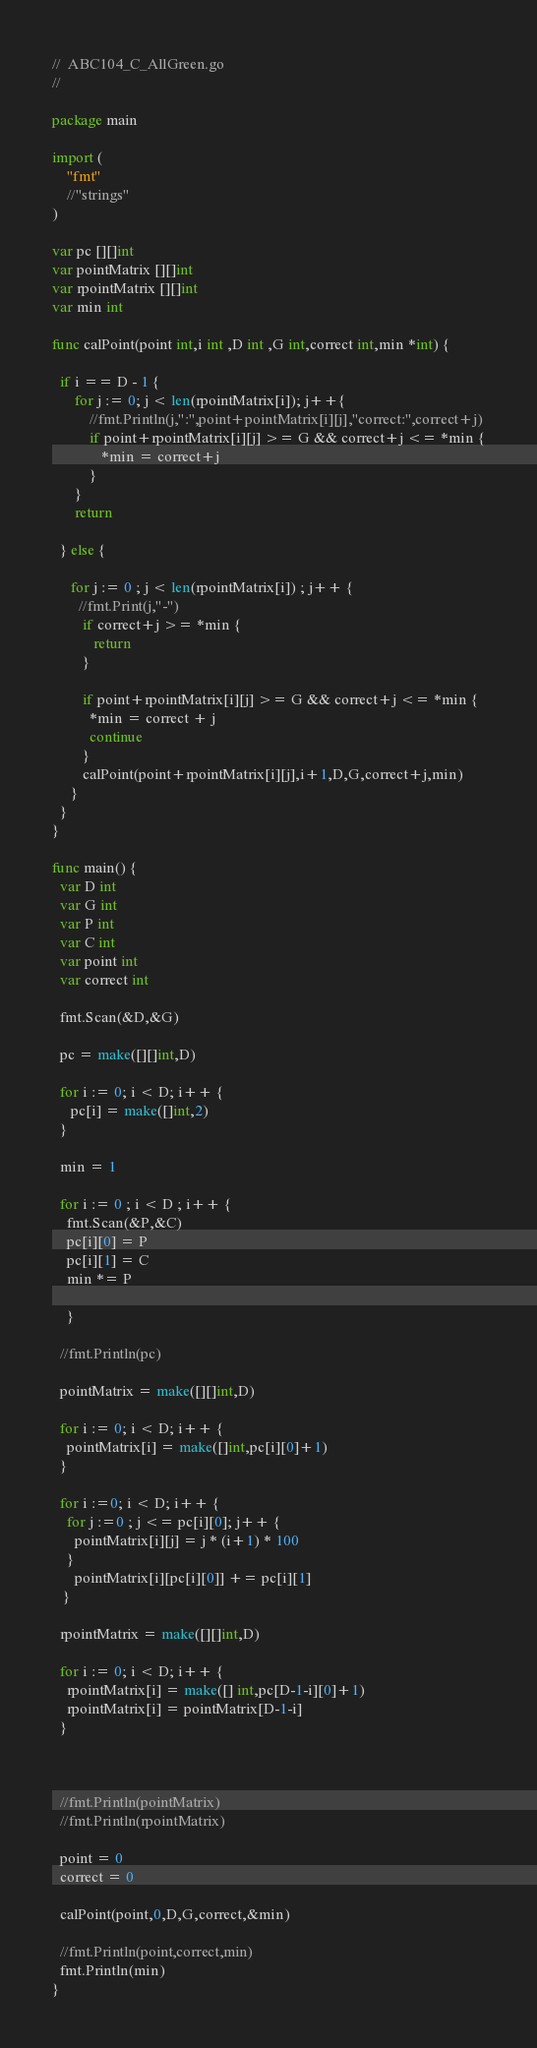<code> <loc_0><loc_0><loc_500><loc_500><_Go_>//  ABC104_C_AllGreen.go
// 

package main

import (
    "fmt"
    //"strings"
)

var pc [][]int
var pointMatrix [][]int
var rpointMatrix [][]int
var min int

func calPoint(point int,i int ,D int ,G int,correct int,min *int) {

  if i == D - 1 {
      for j := 0; j < len(rpointMatrix[i]); j++{
          //fmt.Println(j,":",point+pointMatrix[i][j],"correct:",correct+j)
          if point+rpointMatrix[i][j] >= G && correct+j <= *min {
             *min = correct+j
          }
      }
      return

  } else {

     for j := 0 ; j < len(rpointMatrix[i]) ; j++ {
       //fmt.Print(j,"-")
        if correct+j >= *min {
           return
        }

        if point+rpointMatrix[i][j] >= G && correct+j <= *min {
          *min = correct + j
          continue
        }
        calPoint(point+rpointMatrix[i][j],i+1,D,G,correct+j,min)
     }
  }
}

func main() {
  var D int
  var G int
  var P int
  var C int
  var point int
  var correct int

  fmt.Scan(&D,&G)

  pc = make([][]int,D)

  for i := 0; i < D; i++ {
     pc[i] = make([]int,2)
  }

  min = 1

  for i := 0 ; i < D ; i++ {
    fmt.Scan(&P,&C)
    pc[i][0] = P
    pc[i][1] = C
    min *= P

    }

  //fmt.Println(pc)

  pointMatrix = make([][]int,D)

  for i := 0; i < D; i++ {
    pointMatrix[i] = make([]int,pc[i][0]+1)
  }

  for i :=0; i < D; i++ {
    for j :=0 ; j <= pc[i][0]; j++ {
      pointMatrix[i][j] = j * (i+1) * 100
    }
      pointMatrix[i][pc[i][0]] += pc[i][1]
   }

  rpointMatrix = make([][]int,D)

  for i := 0; i < D; i++ {
    rpointMatrix[i] = make([] int,pc[D-1-i][0]+1)
    rpointMatrix[i] = pointMatrix[D-1-i]
  }



  //fmt.Println(pointMatrix)
  //fmt.Println(rpointMatrix)

  point = 0
  correct = 0

  calPoint(point,0,D,G,correct,&min)

  //fmt.Println(point,correct,min)
  fmt.Println(min)
}


</code> 